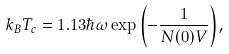<formula> <loc_0><loc_0><loc_500><loc_500>k _ { B } T _ { c } = 1 . 1 3 \hbar { \omega } \exp { \left ( - \frac { 1 } { N ( 0 ) V } \right ) } ,</formula> 